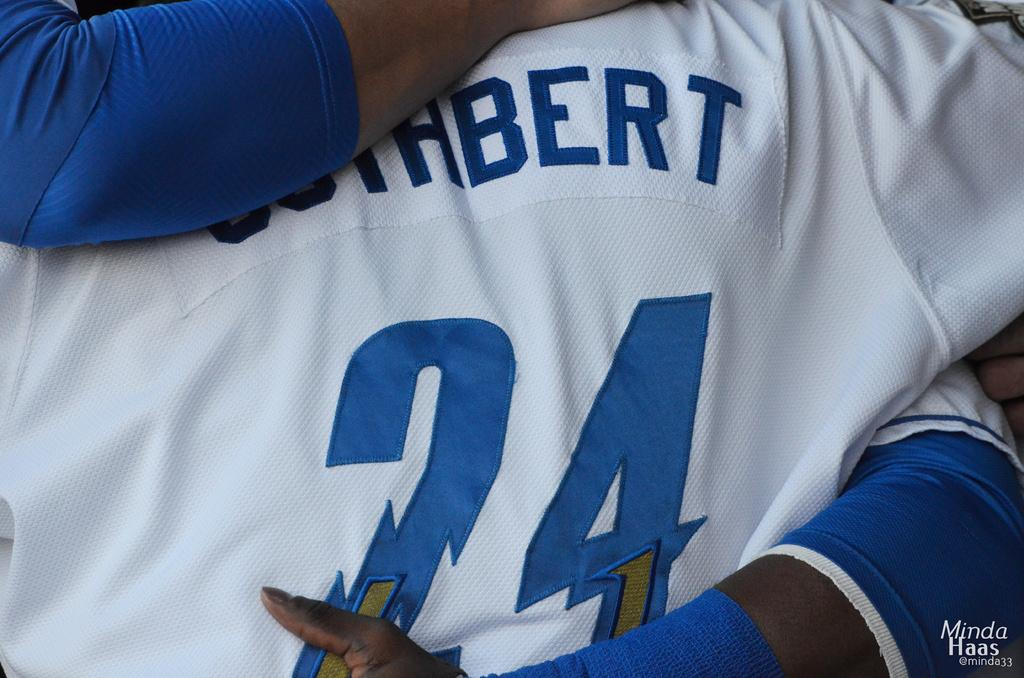<image>
Provide a brief description of the given image. A person wearing jersey number 24 is getting a hug. 